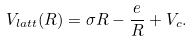<formula> <loc_0><loc_0><loc_500><loc_500>V _ { l a t t } ( R ) = \sigma R - \frac { e } { R } + V _ { c } .</formula> 